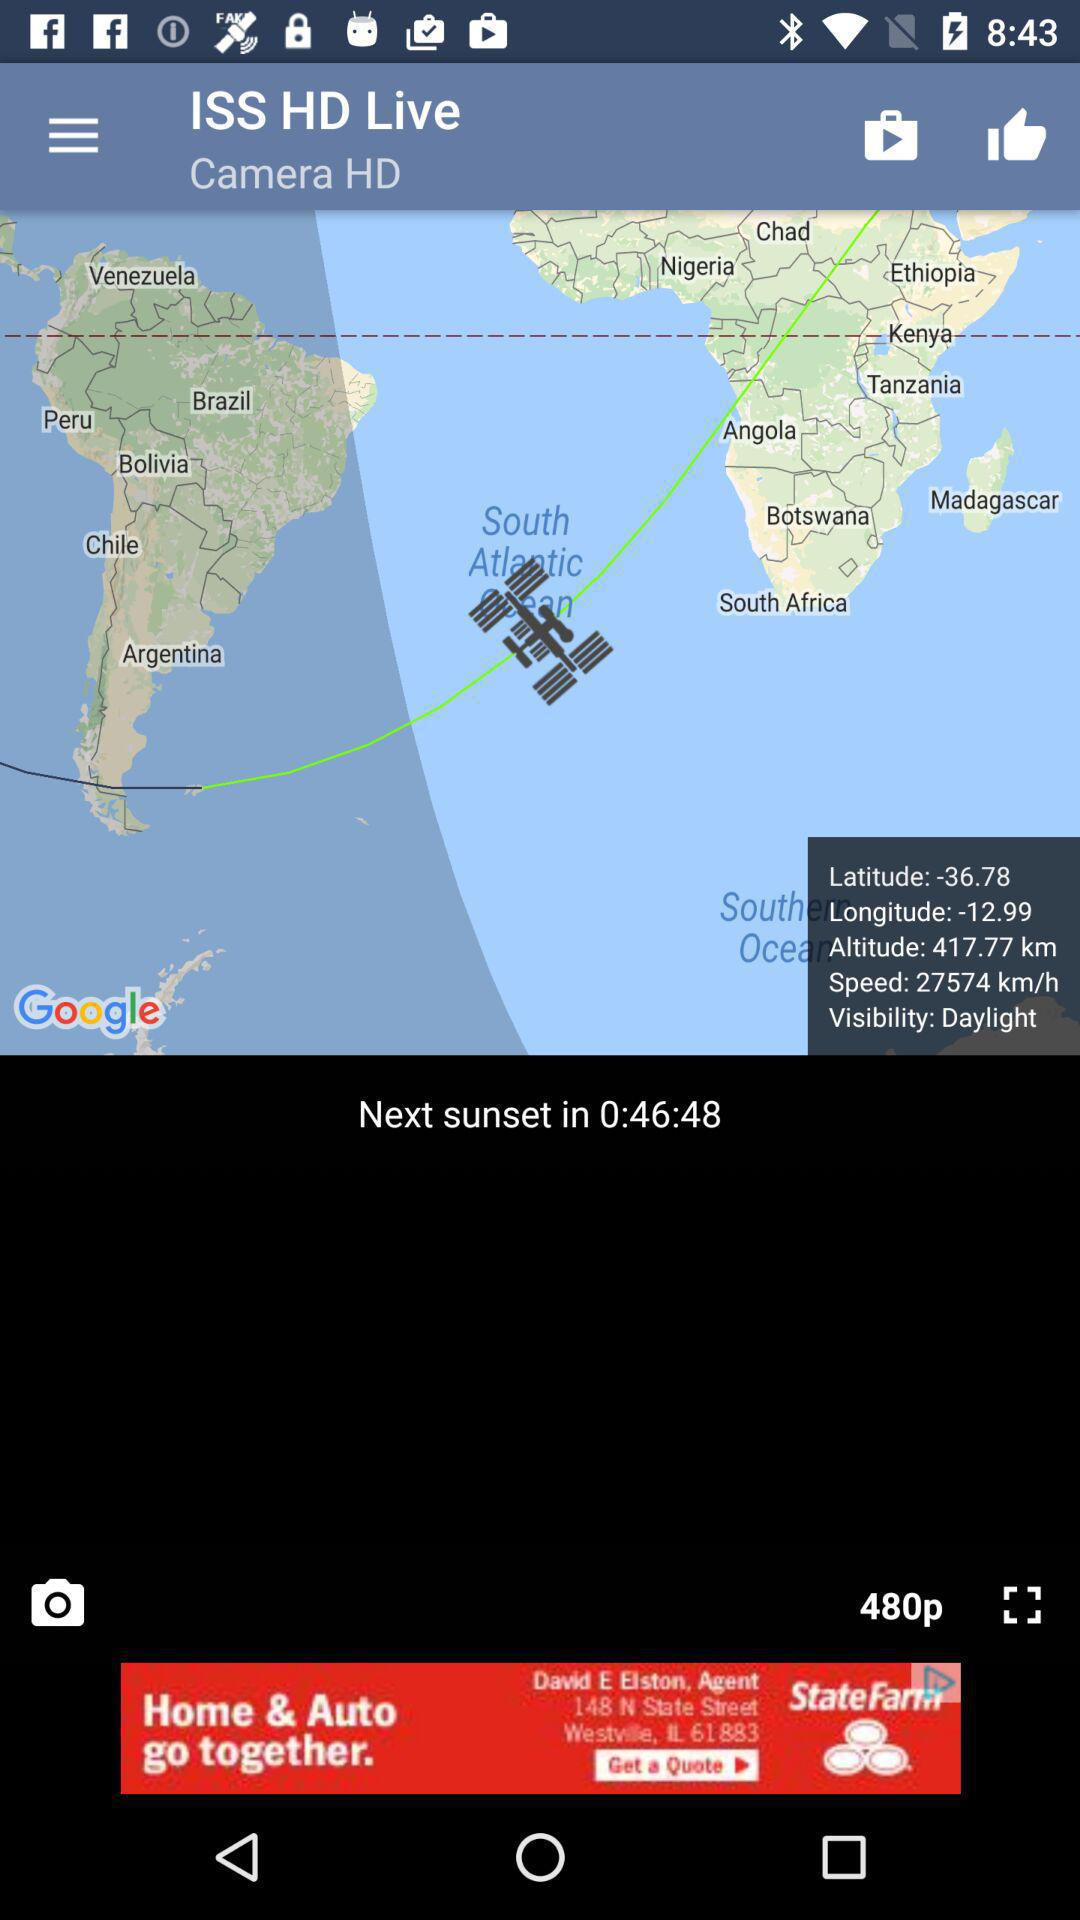What's the video resolution? The video resolution is 480p. 